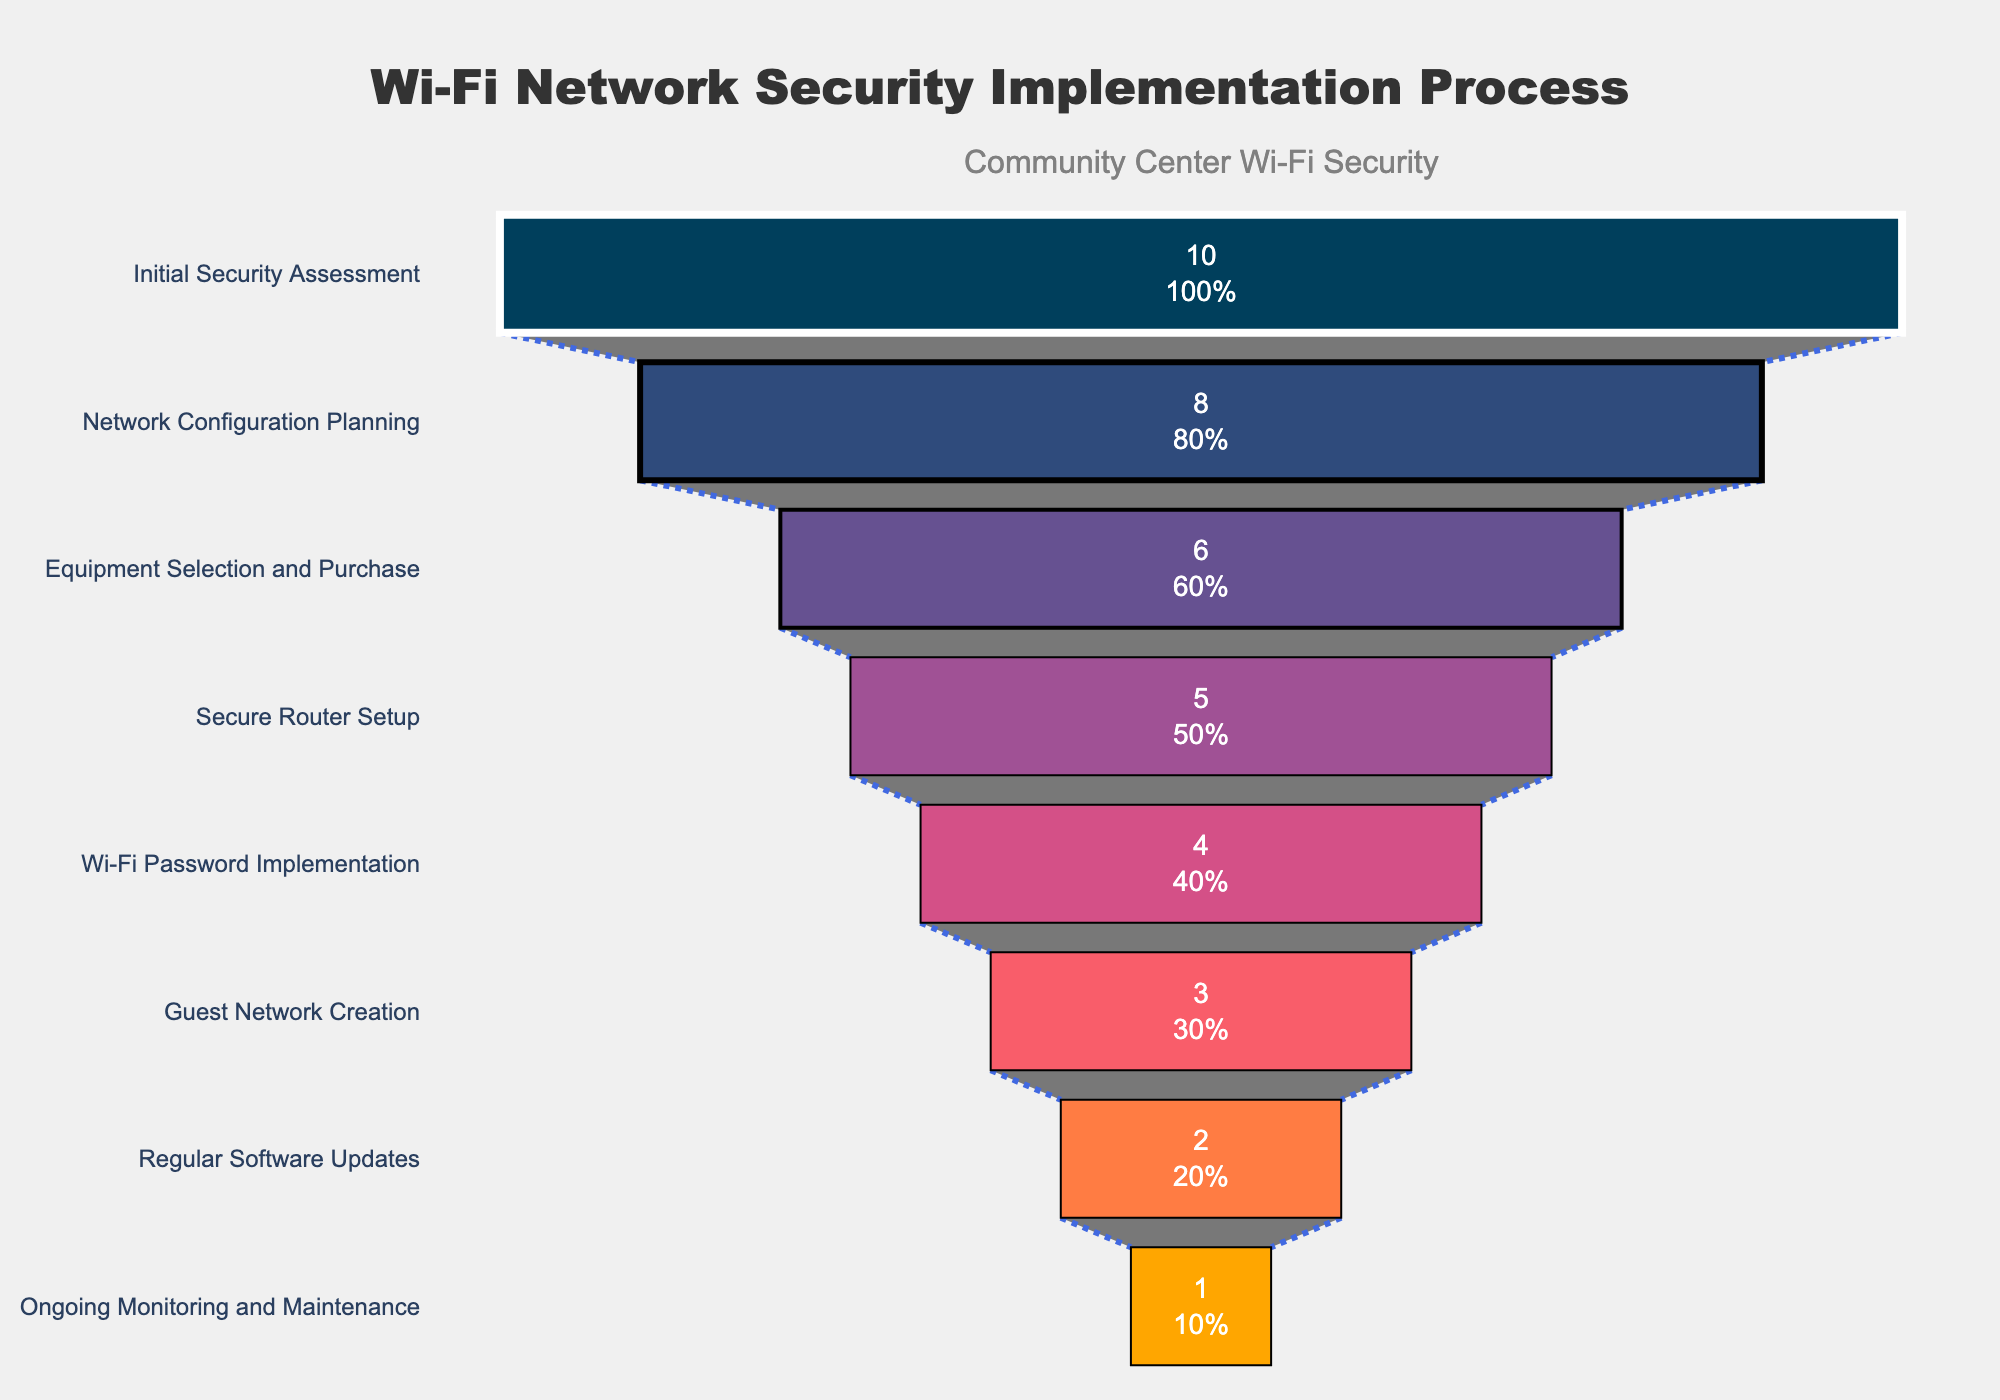What's the title of the figure? The title of the figure is usually placed at the top of the chart. Here, the title is "Wi-Fi Network Security Implementation Process," as indicated by the highlighted section at the top.
Answer: Wi-Fi Network Security Implementation Process How many total steps are involved in the Wi-Fi network security implementation process? The funnel chart lists each step of the Wi-Fi network security implementation process on the y-axis. By counting these steps, we can determine there are eight in total.
Answer: 8 How many tasks are involved in the initial security assessment? The funnel chart shows the number of tasks for each step. The "Initial Security Assessment" has the highest number of tasks, which is 10. This is indicated by the length of the bar associated with this step.
Answer: 10 Which step has the least number of tasks? By looking at the funnel chart's x-axis values, we can observe that "Ongoing Monitoring and Maintenance" has the smallest bar, indicating it has the least number of tasks—only 1 task.
Answer: Ongoing Monitoring and Maintenance Which step comes after the "Wi-Fi Password Implementation"? The funnel chart lists the steps in a hierarchical order from top to bottom. The step immediately following "Wi-Fi Password Implementation" is "Guest Network Creation."
Answer: Guest Network Creation What is the combined total of tasks for the "Guest Network Creation" and "Regular Software Updates" steps? To find the combined total, we add the number of tasks for each of the two steps. "Guest Network Creation" has 3 tasks, and "Regular Software Updates" has 2 tasks. 3 + 2 = 5.
Answer: 5 How does the number of tasks in the "Network Configuration Planning" step compare to the "Secure Router Setup"? "Network Configuration Planning" has 8 tasks, and "Secure Router Setup" has 5 tasks. We compare the numbers and see that "Network Configuration Planning" has more tasks than "Secure Router Setup."
Answer: Network Configuration Planning has more tasks than Secure Router Setup Which step's bar is colored the darkest on the funnel chart? The funnel chart uses color to differentiate between steps. The darkest color is used for the "Initial Security Assessment" step, which is the first one listed in the sequence.
Answer: Initial Security Assessment What percentage of tasks are completed by the end of the "Wi-Fi Password Implementation" step? The funnel chart shows both the number and percentage of tasks for each step. To find the cumulative percentage by the end of the "Wi-Fi Password Implementation," we sum the percentages up through that step. It involves more complex calculation from the percentage displayed on the figure, assuming we use total visible segment of funnel as reference.
Answer: This step will vary by the chart figure exact calculation How much fewer tasks are there in "Equipment Selection and Purchase" compared to "Network Configuration Planning"? We subtract the number of tasks for "Equipment Selection and Purchase" (6) from the number of tasks for "Network Configuration Planning" (8). 8 - 6 = 2.
Answer: 2 tasks fewer 